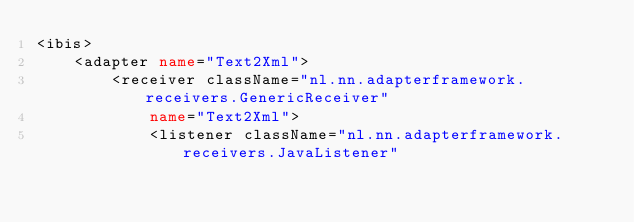<code> <loc_0><loc_0><loc_500><loc_500><_XML_><ibis>
	<adapter name="Text2Xml">
		<receiver className="nl.nn.adapterframework.receivers.GenericReceiver"
			name="Text2Xml">
			<listener className="nl.nn.adapterframework.receivers.JavaListener"</code> 